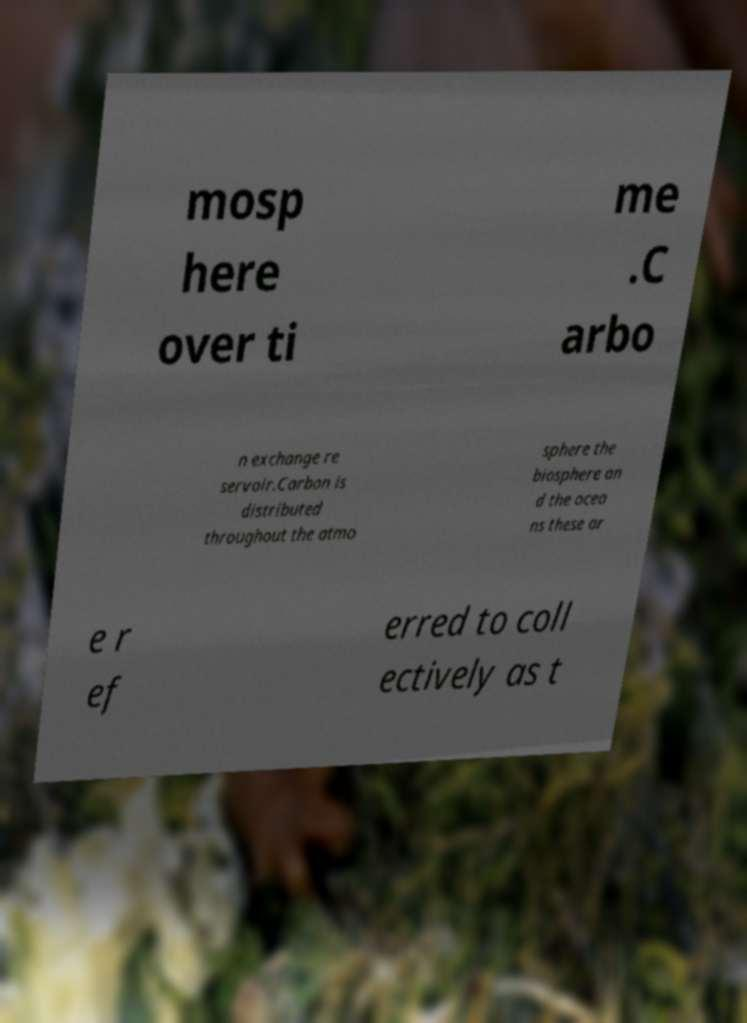Could you assist in decoding the text presented in this image and type it out clearly? mosp here over ti me .C arbo n exchange re servoir.Carbon is distributed throughout the atmo sphere the biosphere an d the ocea ns these ar e r ef erred to coll ectively as t 